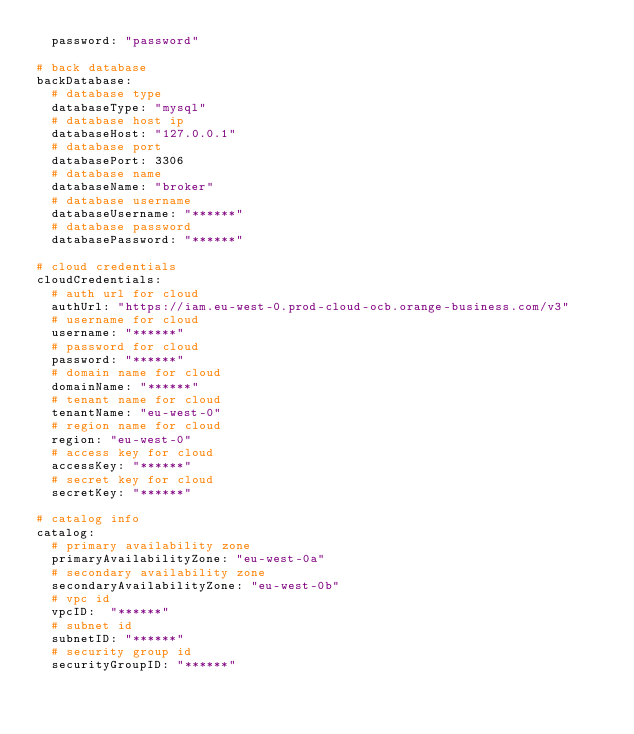<code> <loc_0><loc_0><loc_500><loc_500><_YAML_>  password: "password"

# back database
backDatabase:
  # database type
  databaseType: "mysql"
  # database host ip
  databaseHost: "127.0.0.1"
  # database port
  databasePort: 3306
  # database name
  databaseName: "broker"
  # database username
  databaseUsername: "******"
  # database password
  databasePassword: "******"

# cloud credentials
cloudCredentials:
  # auth url for cloud
  authUrl: "https://iam.eu-west-0.prod-cloud-ocb.orange-business.com/v3"
  # username for cloud
  username: "******"
  # password for cloud
  password: "******"
  # domain name for cloud
  domainName: "******"
  # tenant name for cloud
  tenantName: "eu-west-0"
  # region name for cloud
  region: "eu-west-0"
  # access key for cloud
  accessKey: "******"
  # secret key for cloud
  secretKey: "******"

# catalog info
catalog:
  # primary availability zone
  primaryAvailabilityZone: "eu-west-0a"
  # secondary availability zone
  secondaryAvailabilityZone: "eu-west-0b"
  # vpc id
  vpcID:  "******"
  # subnet id
  subnetID: "******"
  # security group id
  securityGroupID: "******"
</code> 